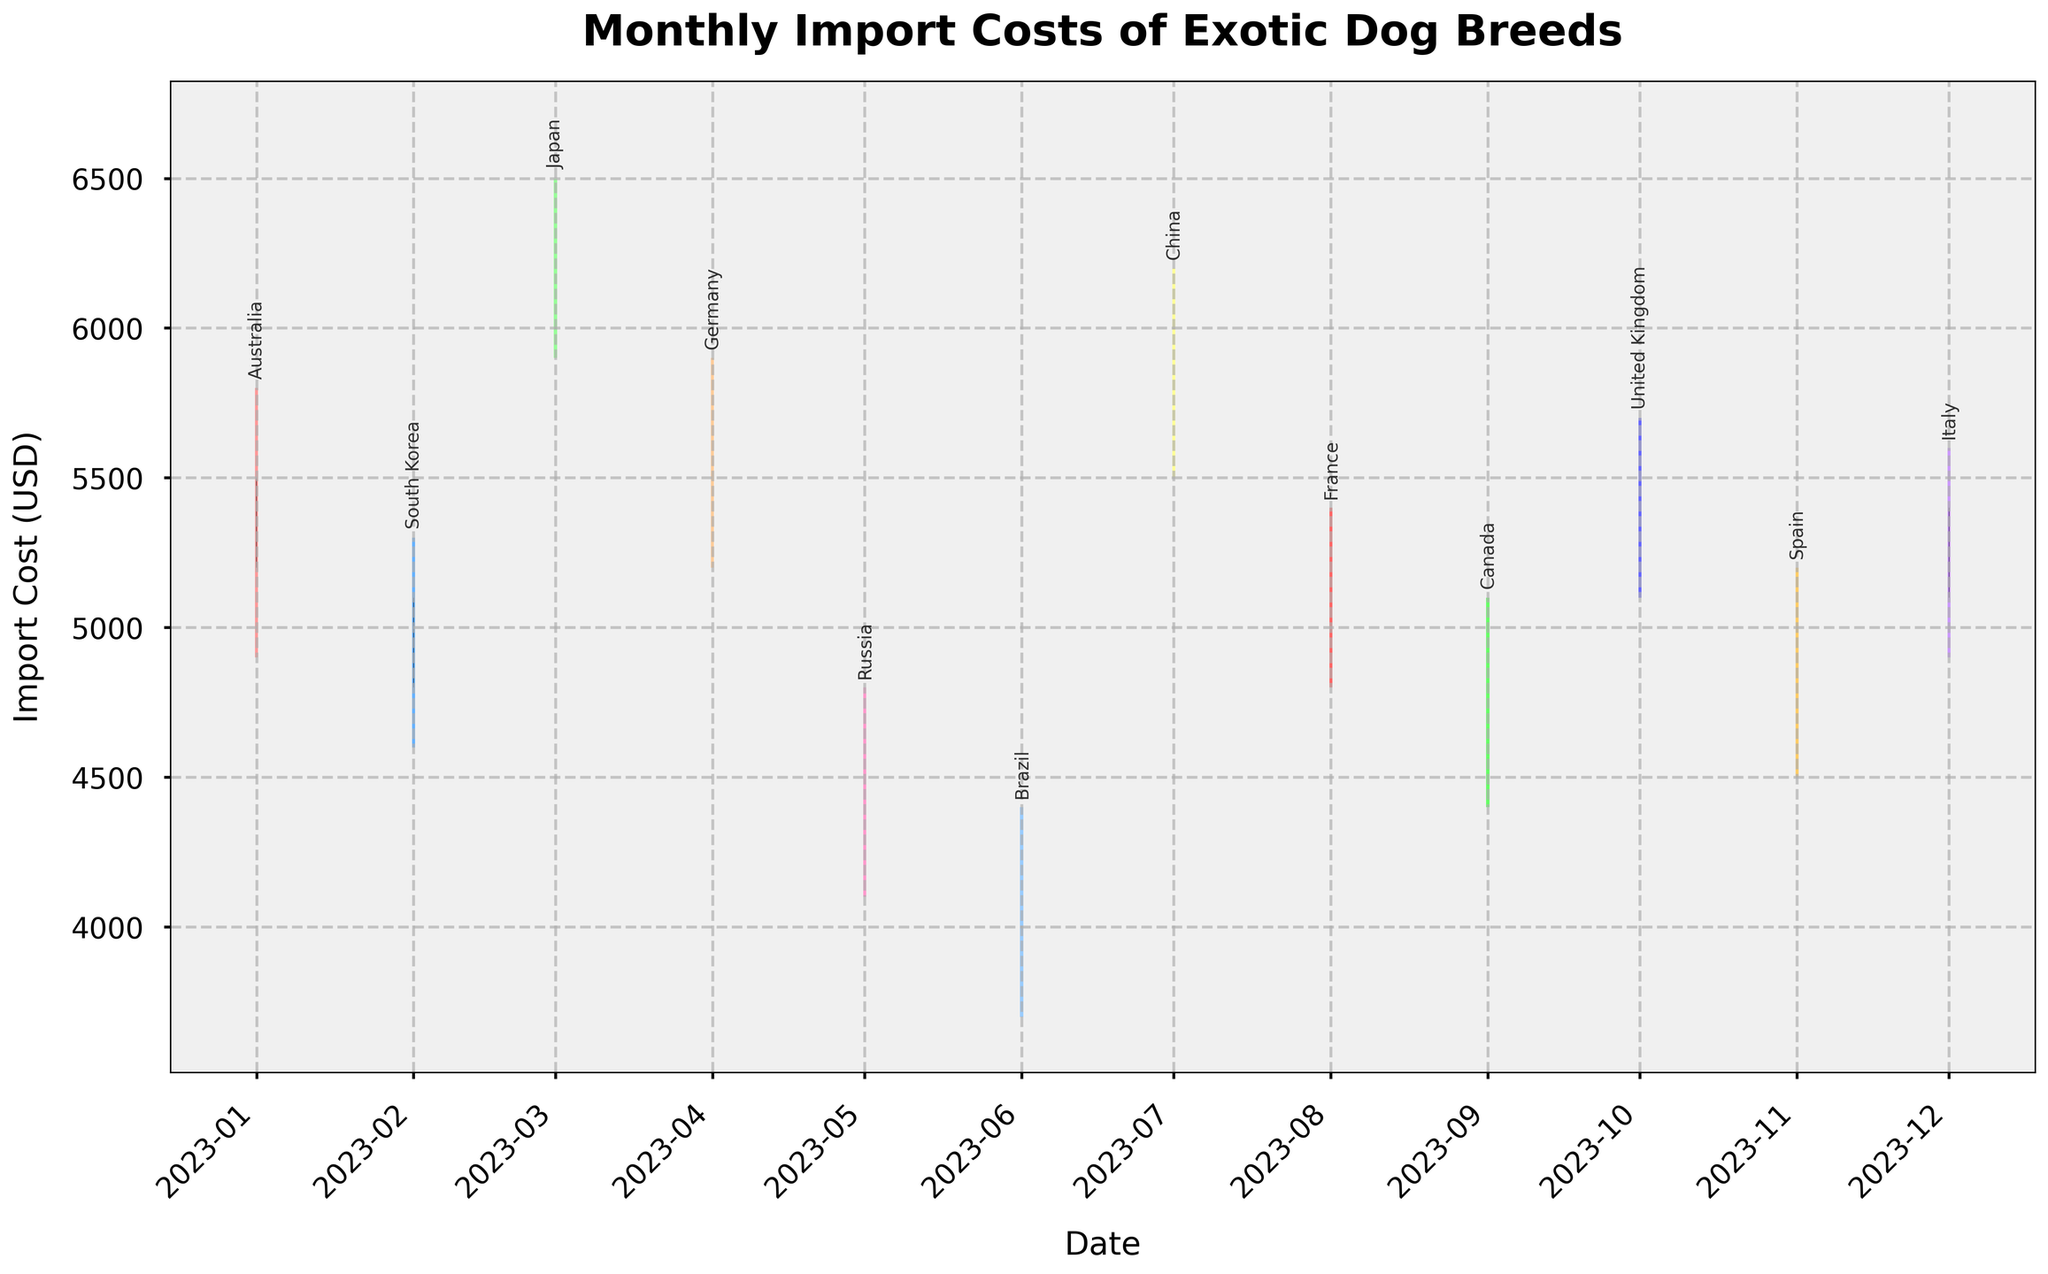Which country has the highest import cost in March 2023? The highest import cost for March 2023 can be seen by looking at the bar that represents the highest value. For March 2023, the highest value is 6500, which corresponds to Japan.
Answer: Japan Which month had the lowest closing value, and what was the value? The closing values can be seen in the bars' connecting lines. The lowest closing value is 4200 in June 2023.
Answer: June 2023; 4200 What was the range of import costs for Germany in April 2023? The range is calculated by subtracting the low value from the high value. For Germany in April 2023, the high value is 5900, and the low value is 5200. The range is 5900 - 5200 = 700.
Answer: 700 Which country shows an increase in import costs from its open value to its close value in November 2023? An increase from open to close is seen when the close value is higher than the open value. For November 2023, the close value (5000) is higher than the open value (4700) for Spain, which indicates an increase.
Answer: Spain During which month did the UK see its highest point reach? To find the highest point for the UK, refer to the high value for October 2023. For the UK, the highest point (5700) is in October.
Answer: October 2023 Compare the highest import values of China and Italy. Which country had a higher peak, and what are the values? The highest import values (points) for China and Italy can be compared. China's highest value is 6200 in July 2023, and Italy's highest value is 5600 in December 2023. Therefore, China had the higher peak (6200).
Answer: China; 6200 What is the median of the highest import costs across the 12 months? Arrange the highest values in ascending order: 4400, 4800, 5100, 5200, 5300, 5400, 5600, 5700, 5800, 5900, 6200, 6500. The median value is the average of the 6th and 7th values (5300 and 5400), so (5300 + 5400) / 2 = 5350.
Answer: 5350 What was the average closing import cost across all the countries for the year 2023? Add up all the closing values and divide by the number of months. (5500 + 5100 + 6300 + 5700 + 4600 + 4200 + 5900 + 5200 + 4900 + 5500 + 5000 + 5400) / 12 = 56400 / 12 = 4700.
Answer: 5250 Which month displayed the smallest difference between its high and low import values? Subtract the low values from the high values for each month and find the smallest difference. The differences are: 900, 700, 600, 700, 700, 700, 600, 600, 700, 600, 700, 800. The smallest difference is 600.
Answer: March 2023, July 2023, October 2023 